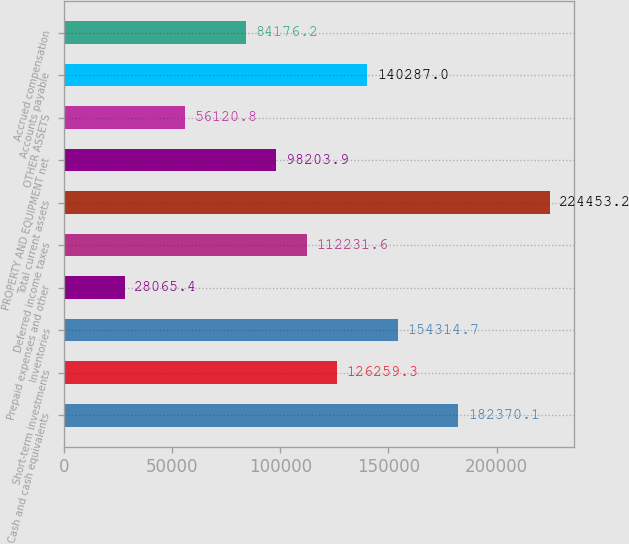Convert chart. <chart><loc_0><loc_0><loc_500><loc_500><bar_chart><fcel>Cash and cash equivalents<fcel>Short-term investments<fcel>Inventories<fcel>Prepaid expenses and other<fcel>Deferred income taxes<fcel>Total current assets<fcel>PROPERTY AND EQUIPMENT net<fcel>OTHER ASSETS<fcel>Accounts payable<fcel>Accrued compensation<nl><fcel>182370<fcel>126259<fcel>154315<fcel>28065.4<fcel>112232<fcel>224453<fcel>98203.9<fcel>56120.8<fcel>140287<fcel>84176.2<nl></chart> 